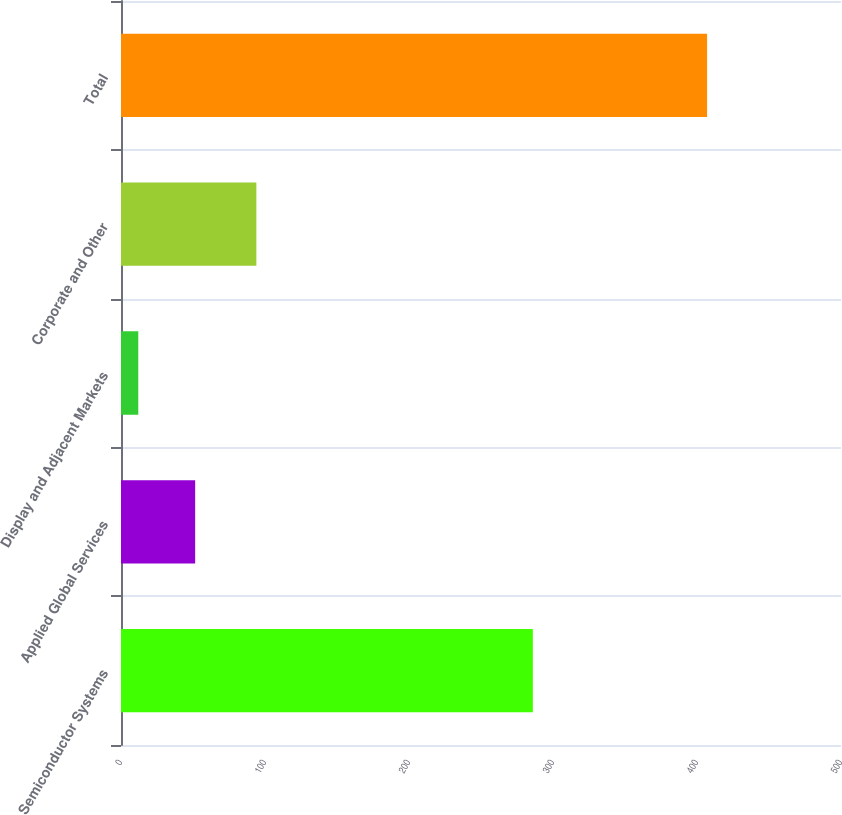<chart> <loc_0><loc_0><loc_500><loc_500><bar_chart><fcel>Semiconductor Systems<fcel>Applied Global Services<fcel>Display and Adjacent Markets<fcel>Corporate and Other<fcel>Total<nl><fcel>286<fcel>51.5<fcel>12<fcel>94<fcel>407<nl></chart> 